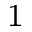Convert formula to latex. <formula><loc_0><loc_0><loc_500><loc_500>_ { 1 }</formula> 